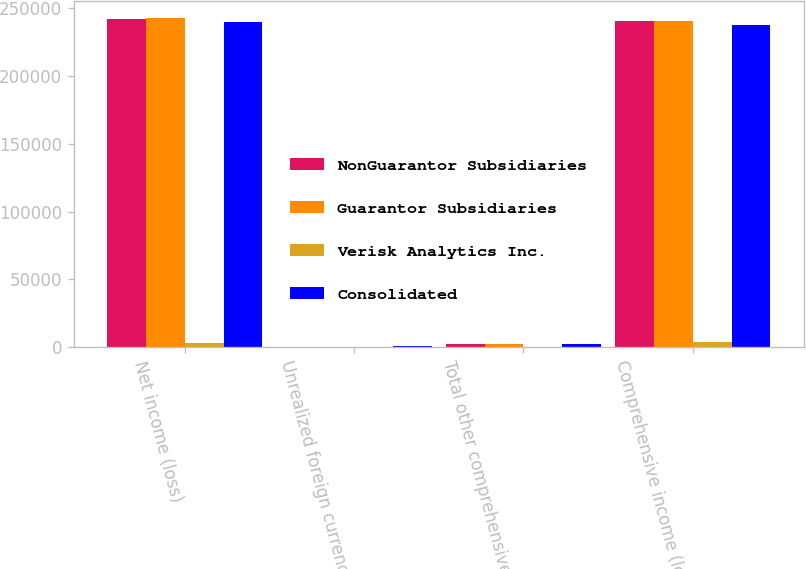<chart> <loc_0><loc_0><loc_500><loc_500><stacked_bar_chart><ecel><fcel>Net income (loss)<fcel>Unrealized foreign currency<fcel>Total other comprehensive loss<fcel>Comprehensive income (loss)<nl><fcel>NonGuarantor Subsidiaries<fcel>242552<fcel>109<fcel>2175<fcel>240377<nl><fcel>Guarantor Subsidiaries<fcel>243147<fcel>109<fcel>2175<fcel>240972<nl><fcel>Verisk Analytics Inc.<fcel>3145<fcel>248<fcel>248<fcel>3393<nl><fcel>Consolidated<fcel>240002<fcel>357<fcel>2423<fcel>237579<nl></chart> 